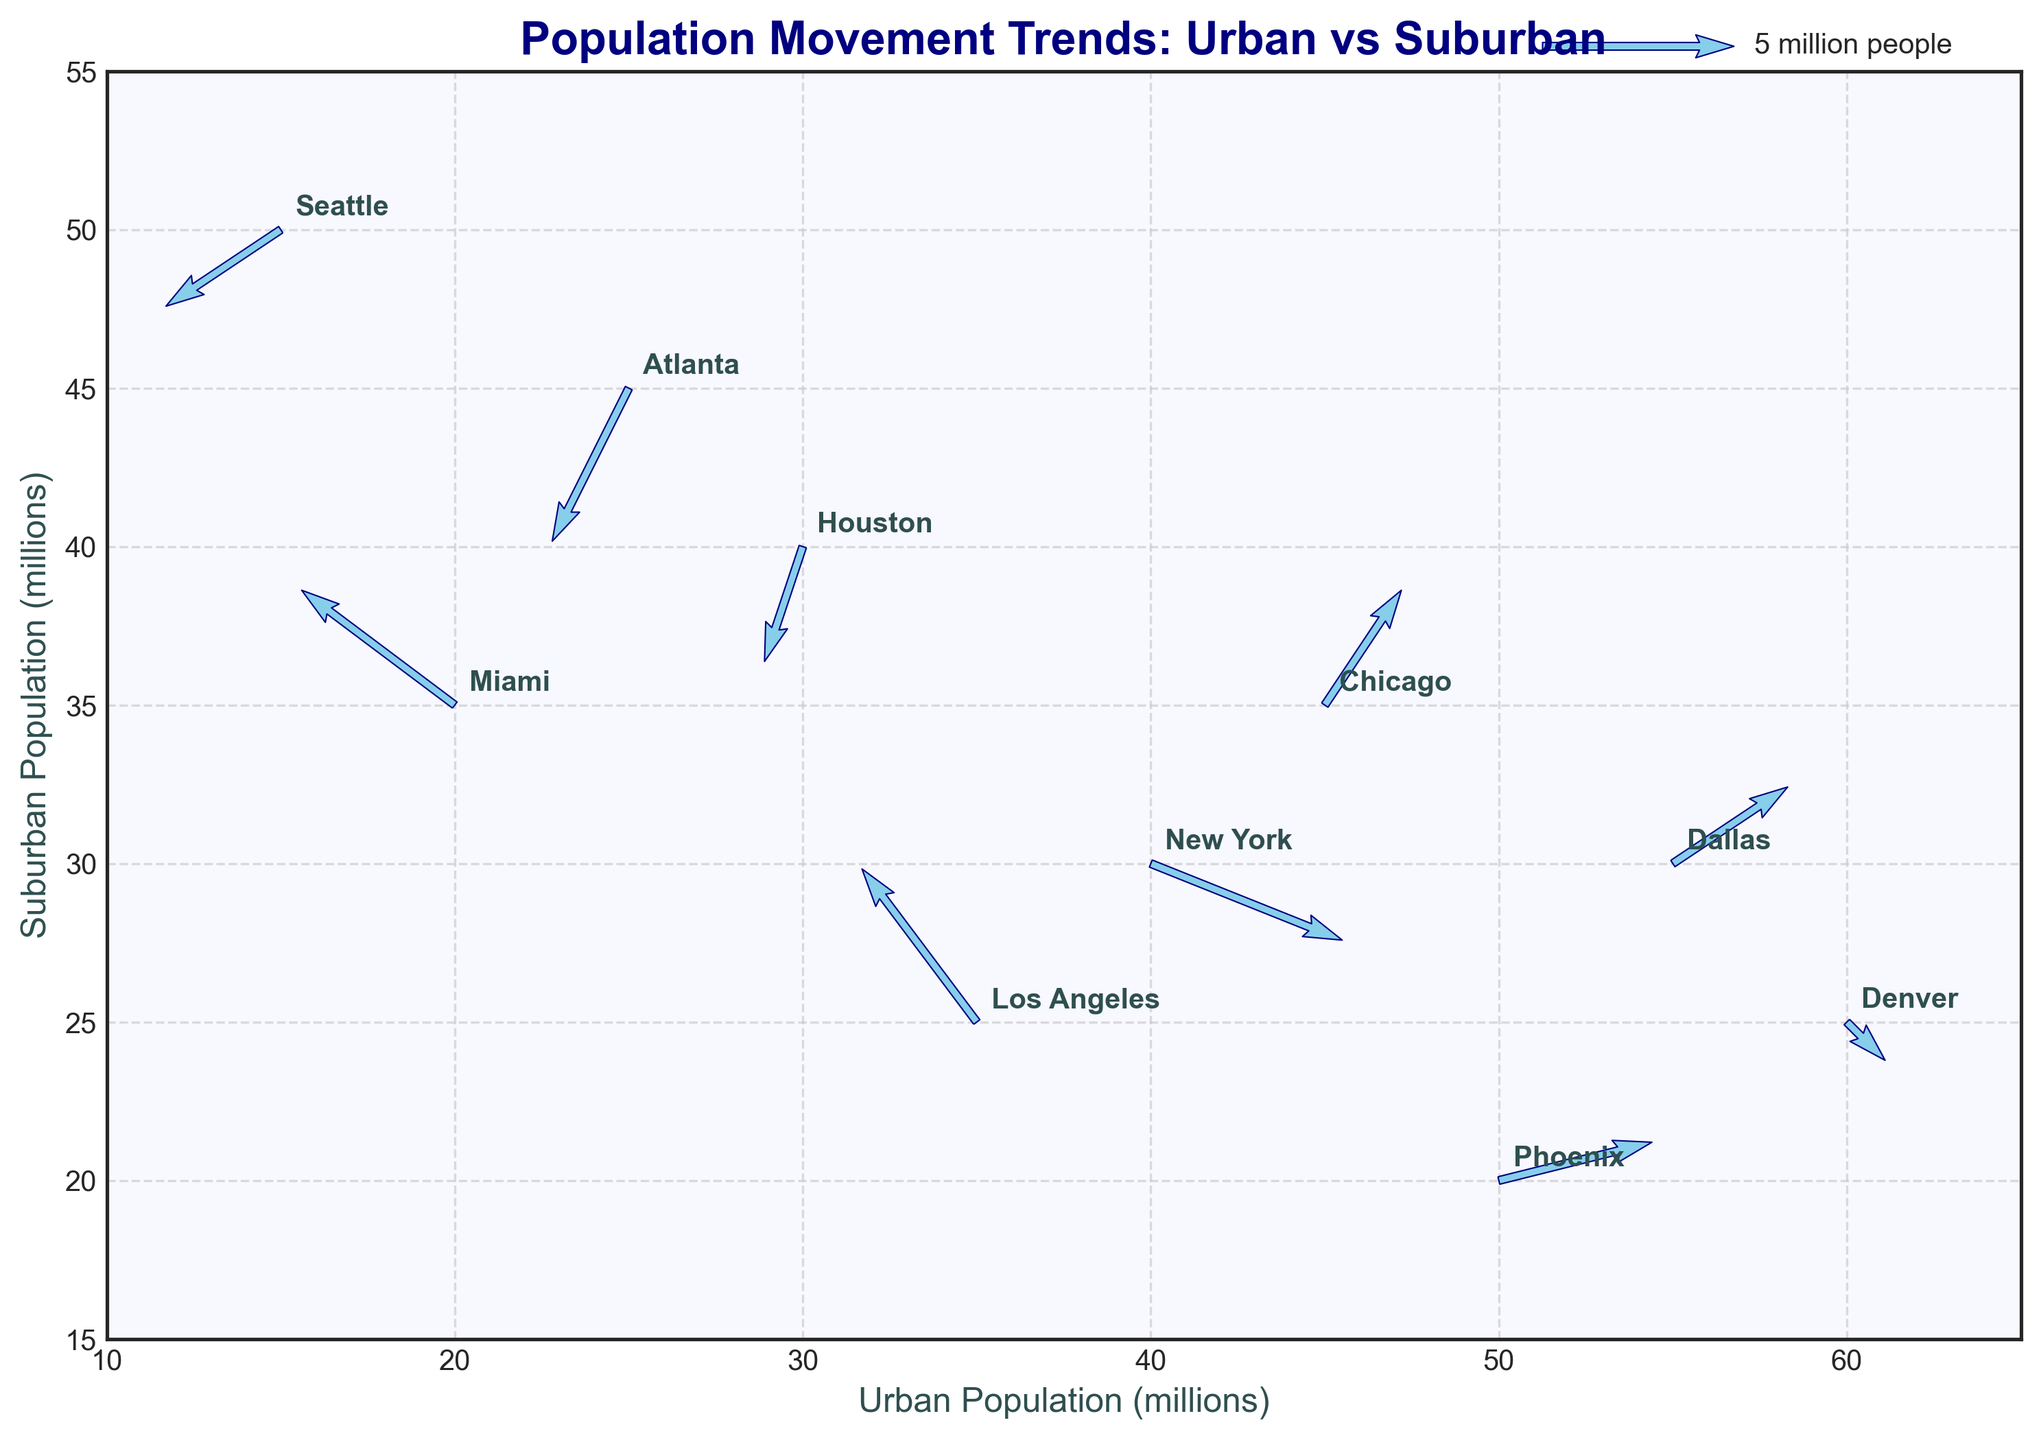Which city represents the highest urban population? The figure has urban population on the x-axis and suburban population on the y-axis. The highest x-value is 60, which corresponds to Denver.
Answer: Denver What is the direction of the population movement in New York? The direction of the arrow for New York shows a right and downward movement, indicating positive movement in the x (urban) direction and negative movement in the y (suburban) direction.
Answer: Towards urban, away from suburban How many cities show a movement towards the suburban population? By examining the direction of the vectors, Los Angeles and Miami both show a positive change in y-direction indicating movement towards suburban populations.
Answer: 2 cities Which city is experiencing the largest decrease in the suburban population? The city with the largest negative y-component in their vector would be the largest decrease in suburban population. Atlanta has a -4 in the y-direction.
Answer: Atlanta Are there any cities with no change in the suburban population? No arrows point directly left or right (indicating a change only in x and not in y), thus all cities show some change in suburban population.
Answer: No Which city has the smallest vector magnitude of population movement? To find the smallest movement magnitude, calculate the magnitude sqrt(u^2 + v^2) for each vector. Houston's vector has a magnitude of sqrt((-1)^2 + (-3)^2) = sqrt(1 + 9) = sqrt(10) ≈ 3.16.
Answer: Houston What is the most common direction of movement, towards urban or suburban areas? By examining the direction of arrows, a majority are moving towards urban areas (x-component is positive).
Answer: Towards urban areas How does Chicago's movement compare with Dallas in terms of magnitude? We calculate the magnitude for both vectors. For Chicago: sqrt(2^2 + 3^2) = sqrt(4 + 9) = sqrt(13) ≈ 3.6. For Dallas: sqrt(3^2 + 2^2) = sqrt(9 + 4) = sqrt(13) ≈ 3.6. Both have the same magnitude.
Answer: Equal magnitude What direction is the movement in Phoenix? Phoenix's vector shows a positive change in both x and y directions, meaning an increase in both urban and suburban populations.
Answer: Towards both urban and suburban Which city has the highest overall population movement? Calculate the magnitude of the vector for each city and find the largest. Miami's vector has the magnitude: sqrt((-4)^2 + 3^2) = sqrt(16 + 9) = sqrt(25) = 5.
Answer: Miami 